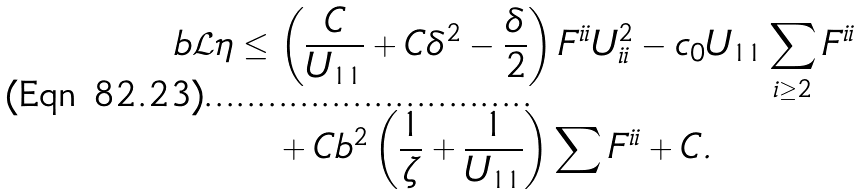Convert formula to latex. <formula><loc_0><loc_0><loc_500><loc_500>b \mathcal { L } \eta \leq \, & \left ( \frac { C } { U _ { 1 1 } } + C \delta ^ { 2 } - \frac { \delta } { 2 } \right ) F ^ { i i } U _ { i i } ^ { 2 } - c _ { 0 } U _ { 1 1 } \sum _ { i \geq 2 } F ^ { i i } \\ & + C b ^ { 2 } \left ( \frac { 1 } { \zeta } + \frac { 1 } { U _ { 1 1 } } \right ) \sum F ^ { i i } + C .</formula> 